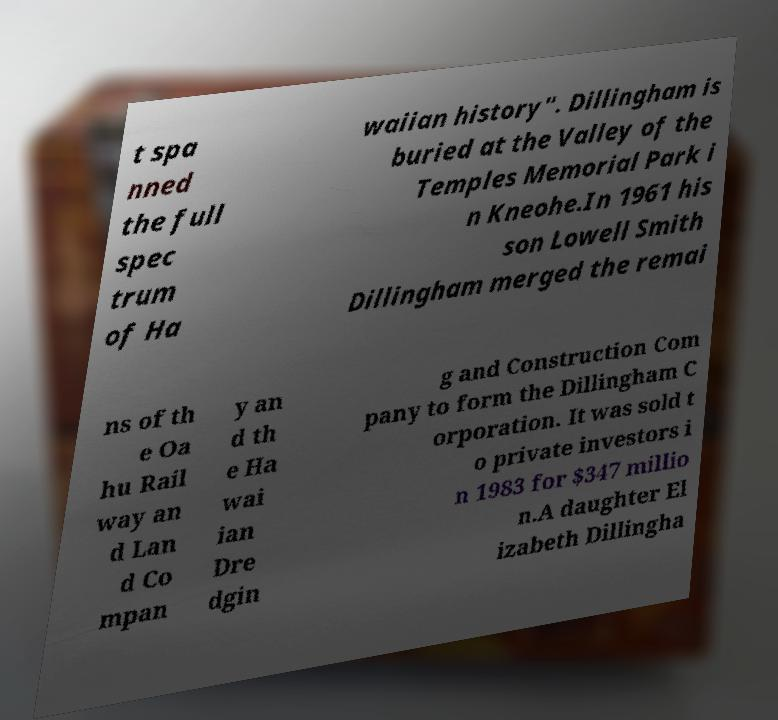Please read and relay the text visible in this image. What does it say? t spa nned the full spec trum of Ha waiian history". Dillingham is buried at the Valley of the Temples Memorial Park i n Kneohe.In 1961 his son Lowell Smith Dillingham merged the remai ns of th e Oa hu Rail way an d Lan d Co mpan y an d th e Ha wai ian Dre dgin g and Construction Com pany to form the Dillingham C orporation. It was sold t o private investors i n 1983 for $347 millio n.A daughter El izabeth Dillingha 